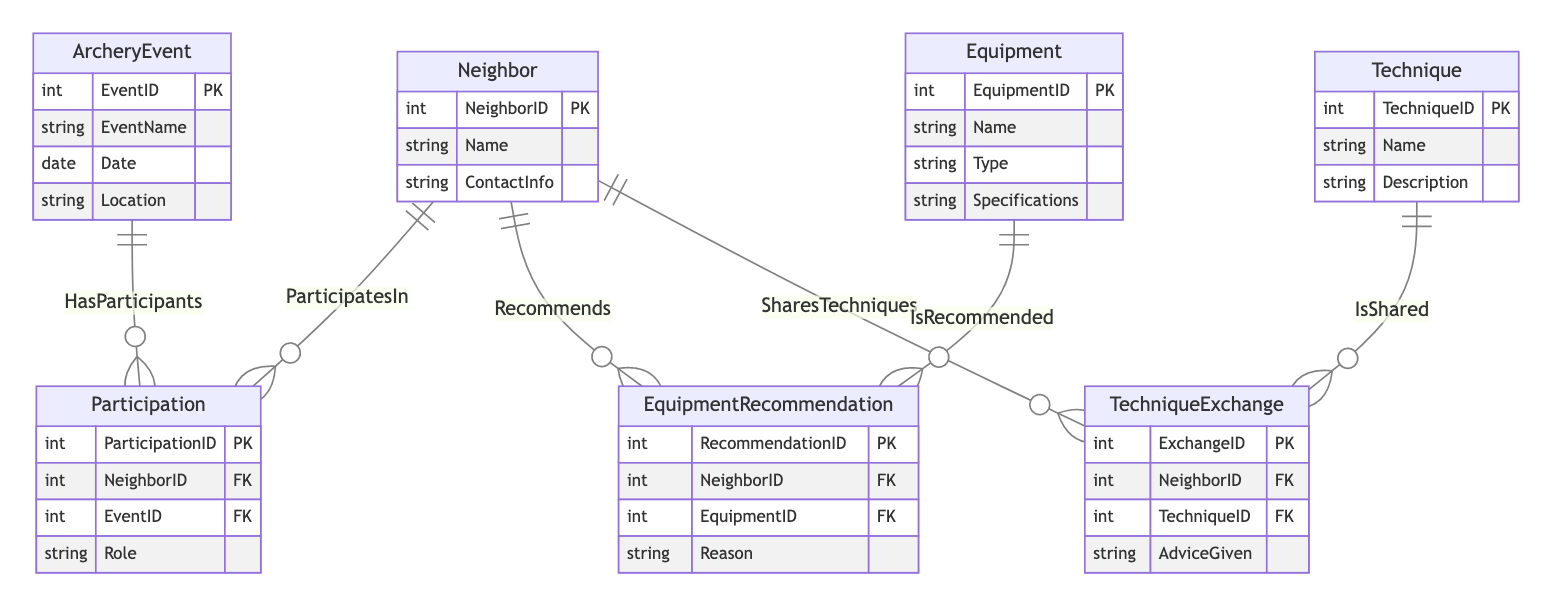What are the attributes of the Neighbor entity? The Neighbor entity has three attributes: NeighborID, Name, and ContactInfo. We can see these listed under the Neighbor entity section in the diagram.
Answer: NeighborID, Name, ContactInfo How many entities are in the diagram? By counting the entities listed in the diagram, we see there are a total of six entities: Neighbor, ArcheryEvent, Participation, Technique, Equipment, and TechniqueExchange.
Answer: 6 What is the relationship between Neighbor and ArcheryEvent? The relationship is named "ParticipatesIn," indicating that neighbors can participate in multiple archery events. This relationship is clearly shown in the diagram connecting these two entities.
Answer: ParticipatesIn Which entity shares techniques? The TechniqueExchange entity represents the sharing of techniques among neighbors, as highlighted in the relationships section connecting it with the Neighbor entity.
Answer: TechniqueExchange What is the foreign key in the Participation entity? The Participation entity has two foreign keys: NeighborID and EventID, which reference the Neighbor and ArcheryEvent entities, respectively. This is indicated by the PK and FK notation in the diagram.
Answer: NeighborID, EventID How many ways can a Neighbor recommend equipment? A neighbor can recommend equipment through the EquipmentRecommendation entity, which is the only entity that specifically handles recommendations. This is shown in the diagram connecting the Neighbor to Equipment.
Answer: 1 What are the attributes of the Technique entity? The Technique entity includes three attributes: TechniqueID, Name, and Description, reflecting its properties as displayed in the diagram.
Answer: TechniqueID, Name, Description What is the primary key of the EquipmentRecommendation entity? The primary key of the EquipmentRecommendation entity is RecommendationID, which uniquely identifies each recommendation made by a neighbor. It is marked as PK in the diagram.
Answer: RecommendationID What is the role of a neighbor in the Participation entity? The role of a neighbor in the Participation entity is specified by the attribute "Role," indicating the capacity in which a neighbor engages in the archery event.
Answer: Role 